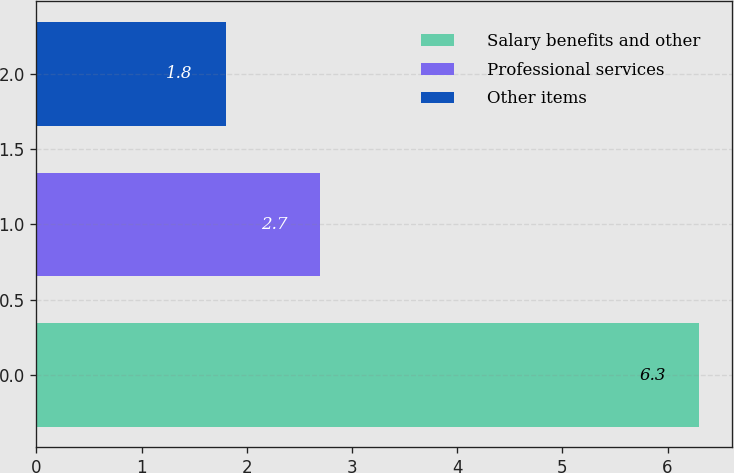Convert chart. <chart><loc_0><loc_0><loc_500><loc_500><bar_chart><fcel>Salary benefits and other<fcel>Professional services<fcel>Other items<nl><fcel>6.3<fcel>2.7<fcel>1.8<nl></chart> 